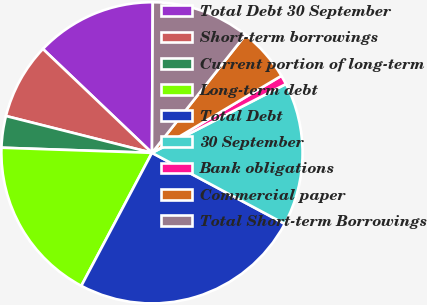Convert chart to OTSL. <chart><loc_0><loc_0><loc_500><loc_500><pie_chart><fcel>Total Debt 30 September<fcel>Short-term borrowings<fcel>Current portion of long-term<fcel>Long-term debt<fcel>Total Debt<fcel>30 September<fcel>Bank obligations<fcel>Commercial paper<fcel>Total Short-term Borrowings<nl><fcel>12.97%<fcel>8.18%<fcel>3.39%<fcel>17.77%<fcel>24.95%<fcel>15.37%<fcel>0.99%<fcel>5.79%<fcel>10.58%<nl></chart> 